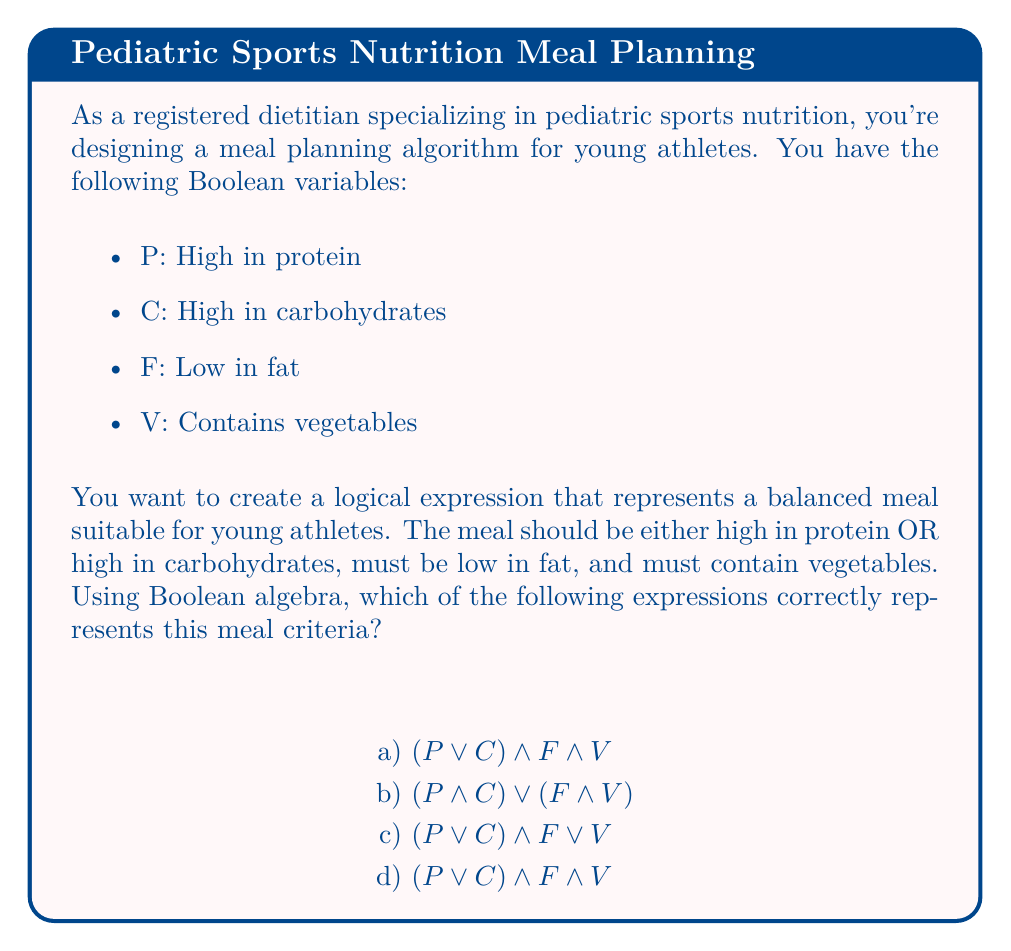Can you solve this math problem? Let's break this down step-by-step:

1) First, let's identify the key components of the meal criteria:
   - Either high in protein OR high in carbohydrates: $(P \lor C)$
   - Must be low in fat: $F$
   - Must contain vegetables: $V$

2) Now, we need to combine these components using logical operators:
   - The meal should satisfy all these criteria, so we use the AND operator $\land$ to connect them.

3) The correct logical expression should be:
   $$(P \lor C) \land F \land V$$

4) Let's evaluate each option:

   a) $$(P \lor C) \land F \land V$$ 
      This matches our reasoning exactly.

   b) $$(P \land C) \lor (F \land V)$$ 
      This would mean the meal is high in both protein AND carbs, OR low in fat AND contains vegetables. This doesn't match our criteria.

   c) $$(P \lor C) \land F \lor V$$ 
      This would allow a meal that's either (high in protein or carbs AND low in fat) OR contains vegetables. The vegetable requirement isn't properly connected.

   d) $$(P \lor C) \land F \land V$$ 
      This is identical to option a) and correctly represents our criteria.

5) Therefore, both options a) and d) are correct representations of the meal criteria.
Answer: a) and d) $$(P \lor C) \land F \land V$$ 